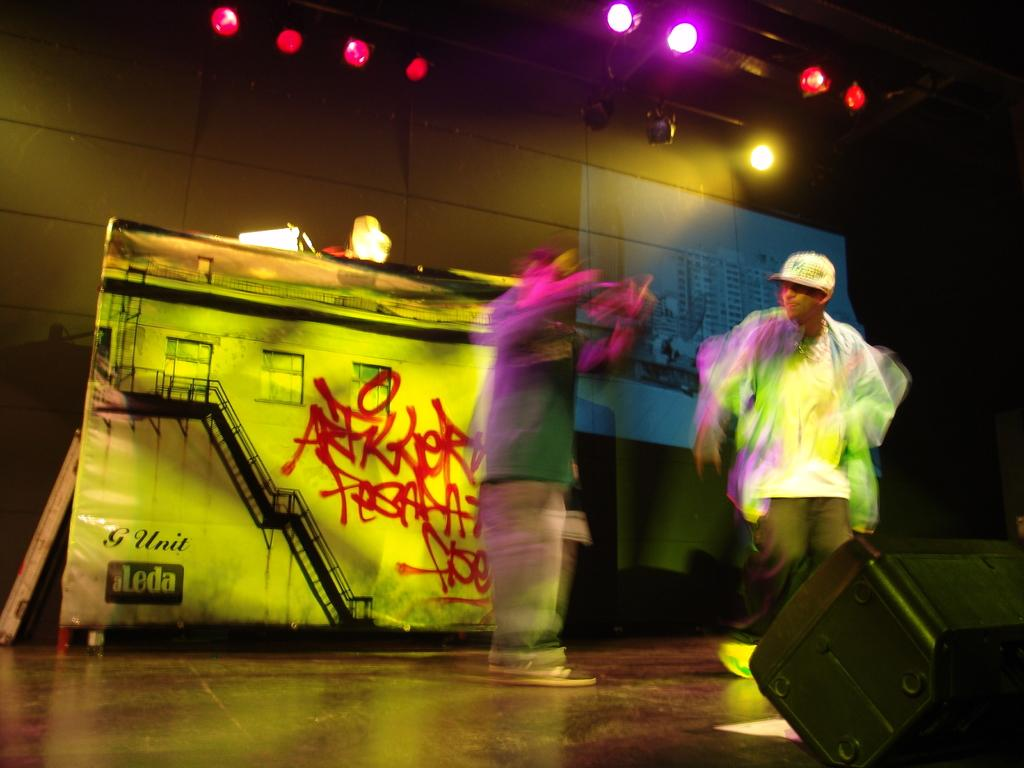How many people are on the stage in the image? There are two people on the stage in the image. What can be seen in the background of the image? There is a wall in the background of the image. What type of ants can be seen crawling on the ground in the image? There are no ants or ground visible in the image; it features two people on a stage with a wall in the background. 